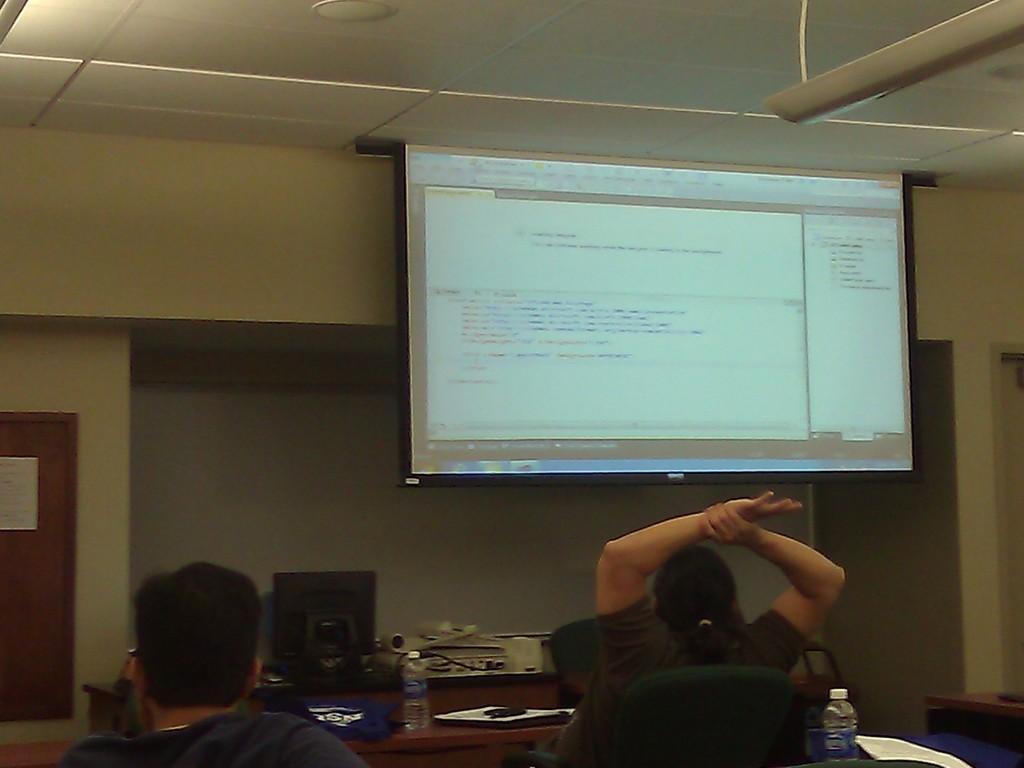How would you summarize this image in a sentence or two? This is a picture taken in a room, there are two persons sitting on chairs in front of these people there is a table on the table there are bottle, paper, pen, monitor and some machines. In front of these people there is a projector screen and a wall on the wall there is a wooden board. 